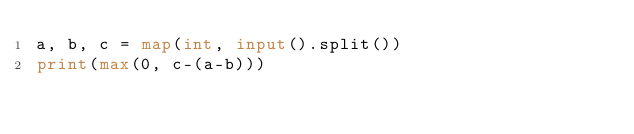Convert code to text. <code><loc_0><loc_0><loc_500><loc_500><_Python_>a, b, c = map(int, input().split())
print(max(0, c-(a-b)))</code> 